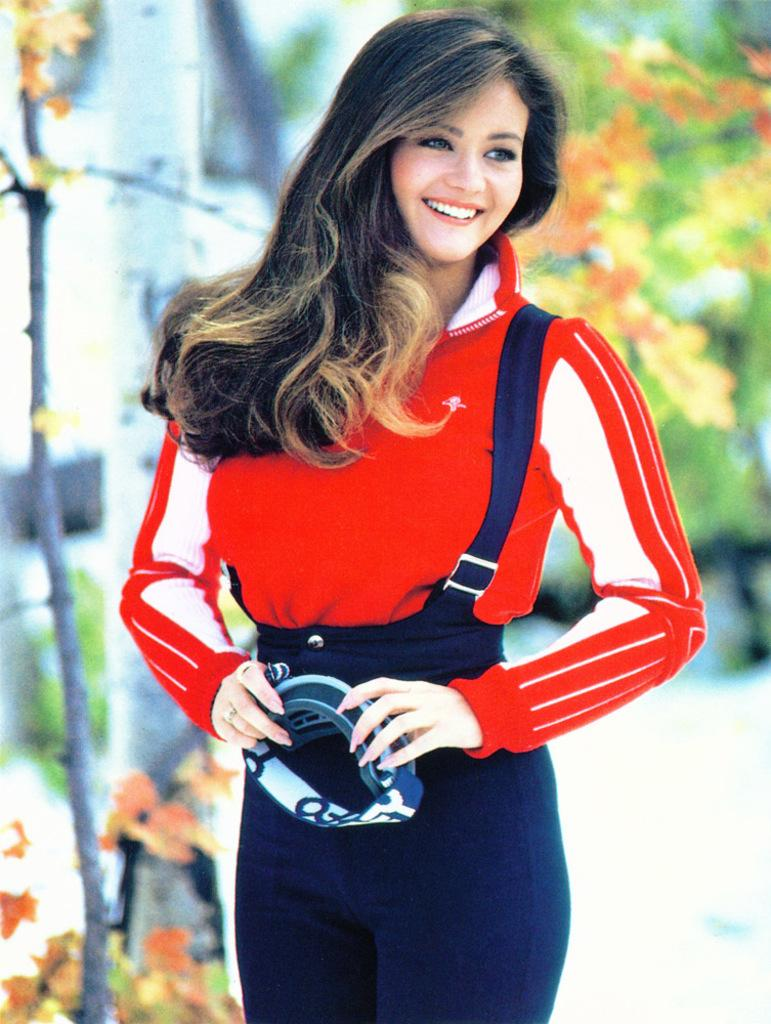What is the main subject of the image? There is a woman in the image. What is the woman doing in the image? The woman is standing in the image. What is the woman holding in the image? The woman is holding an object in the image. What is the woman wearing in the image? The woman is wearing a red t-shirt in the image. What can be seen in the background of the image? There are branches and leaves in the image. How would you describe the background of the image? The background of the image is blurry. How many babies are present in the image? There are no babies present in the image; it features a woman standing and holding an object. 